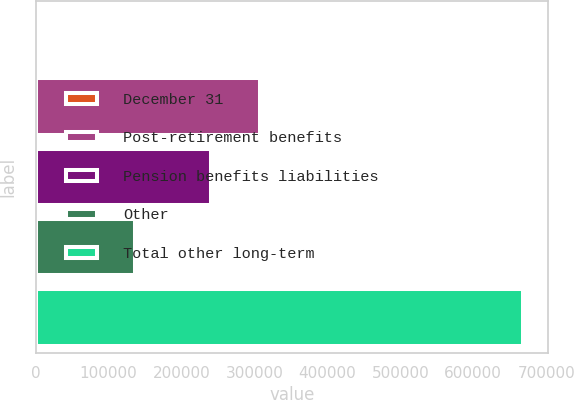Convert chart. <chart><loc_0><loc_0><loc_500><loc_500><bar_chart><fcel>December 31<fcel>Post-retirement benefits<fcel>Pension benefits liabilities<fcel>Other<fcel>Total other long-term<nl><fcel>2012<fcel>306887<fcel>240215<fcel>136283<fcel>668732<nl></chart> 